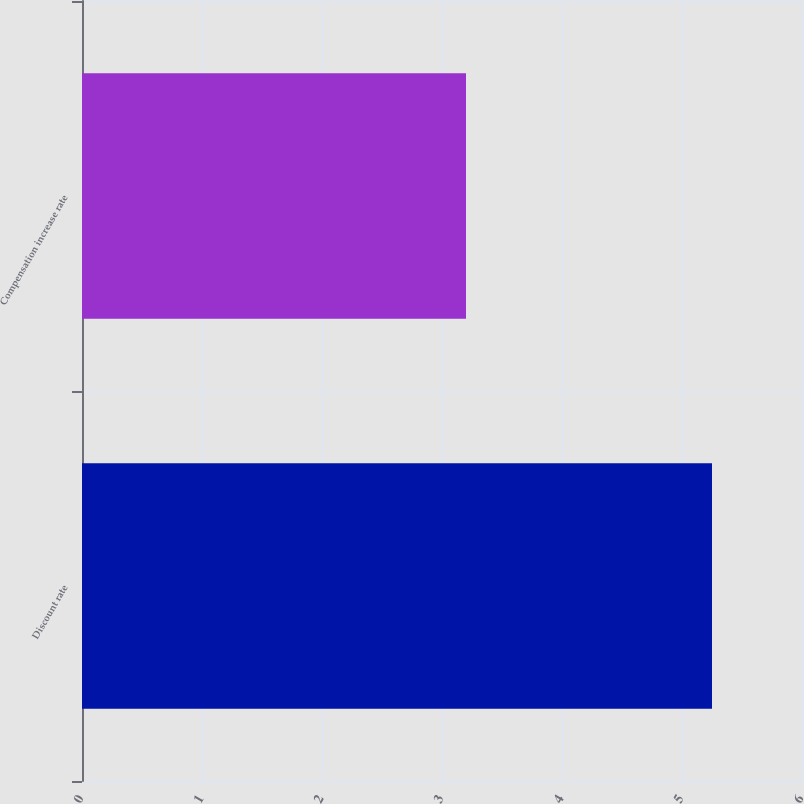Convert chart. <chart><loc_0><loc_0><loc_500><loc_500><bar_chart><fcel>Discount rate<fcel>Compensation increase rate<nl><fcel>5.25<fcel>3.2<nl></chart> 